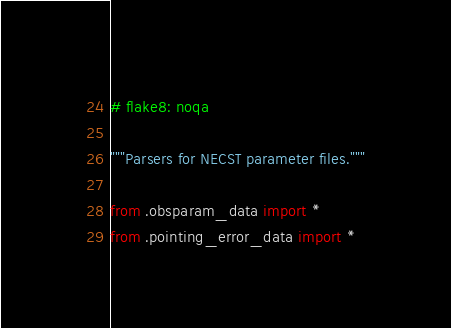Convert code to text. <code><loc_0><loc_0><loc_500><loc_500><_Python_># flake8: noqa

"""Parsers for NECST parameter files."""

from .obsparam_data import *
from .pointing_error_data import *
</code> 